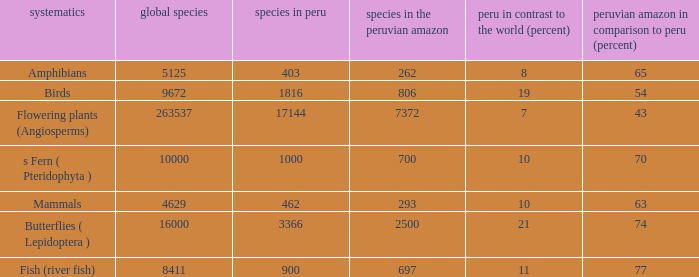What's the minimum species in the peruvian amazon with peru vs. world (percent) value of 7 7372.0. 